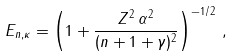<formula> <loc_0><loc_0><loc_500><loc_500>E _ { n , \kappa } = \left ( 1 + \frac { Z ^ { 2 } \, \alpha ^ { 2 } } { ( n + 1 + \gamma ) ^ { 2 } } \right ) ^ { - 1 / 2 } \, ,</formula> 